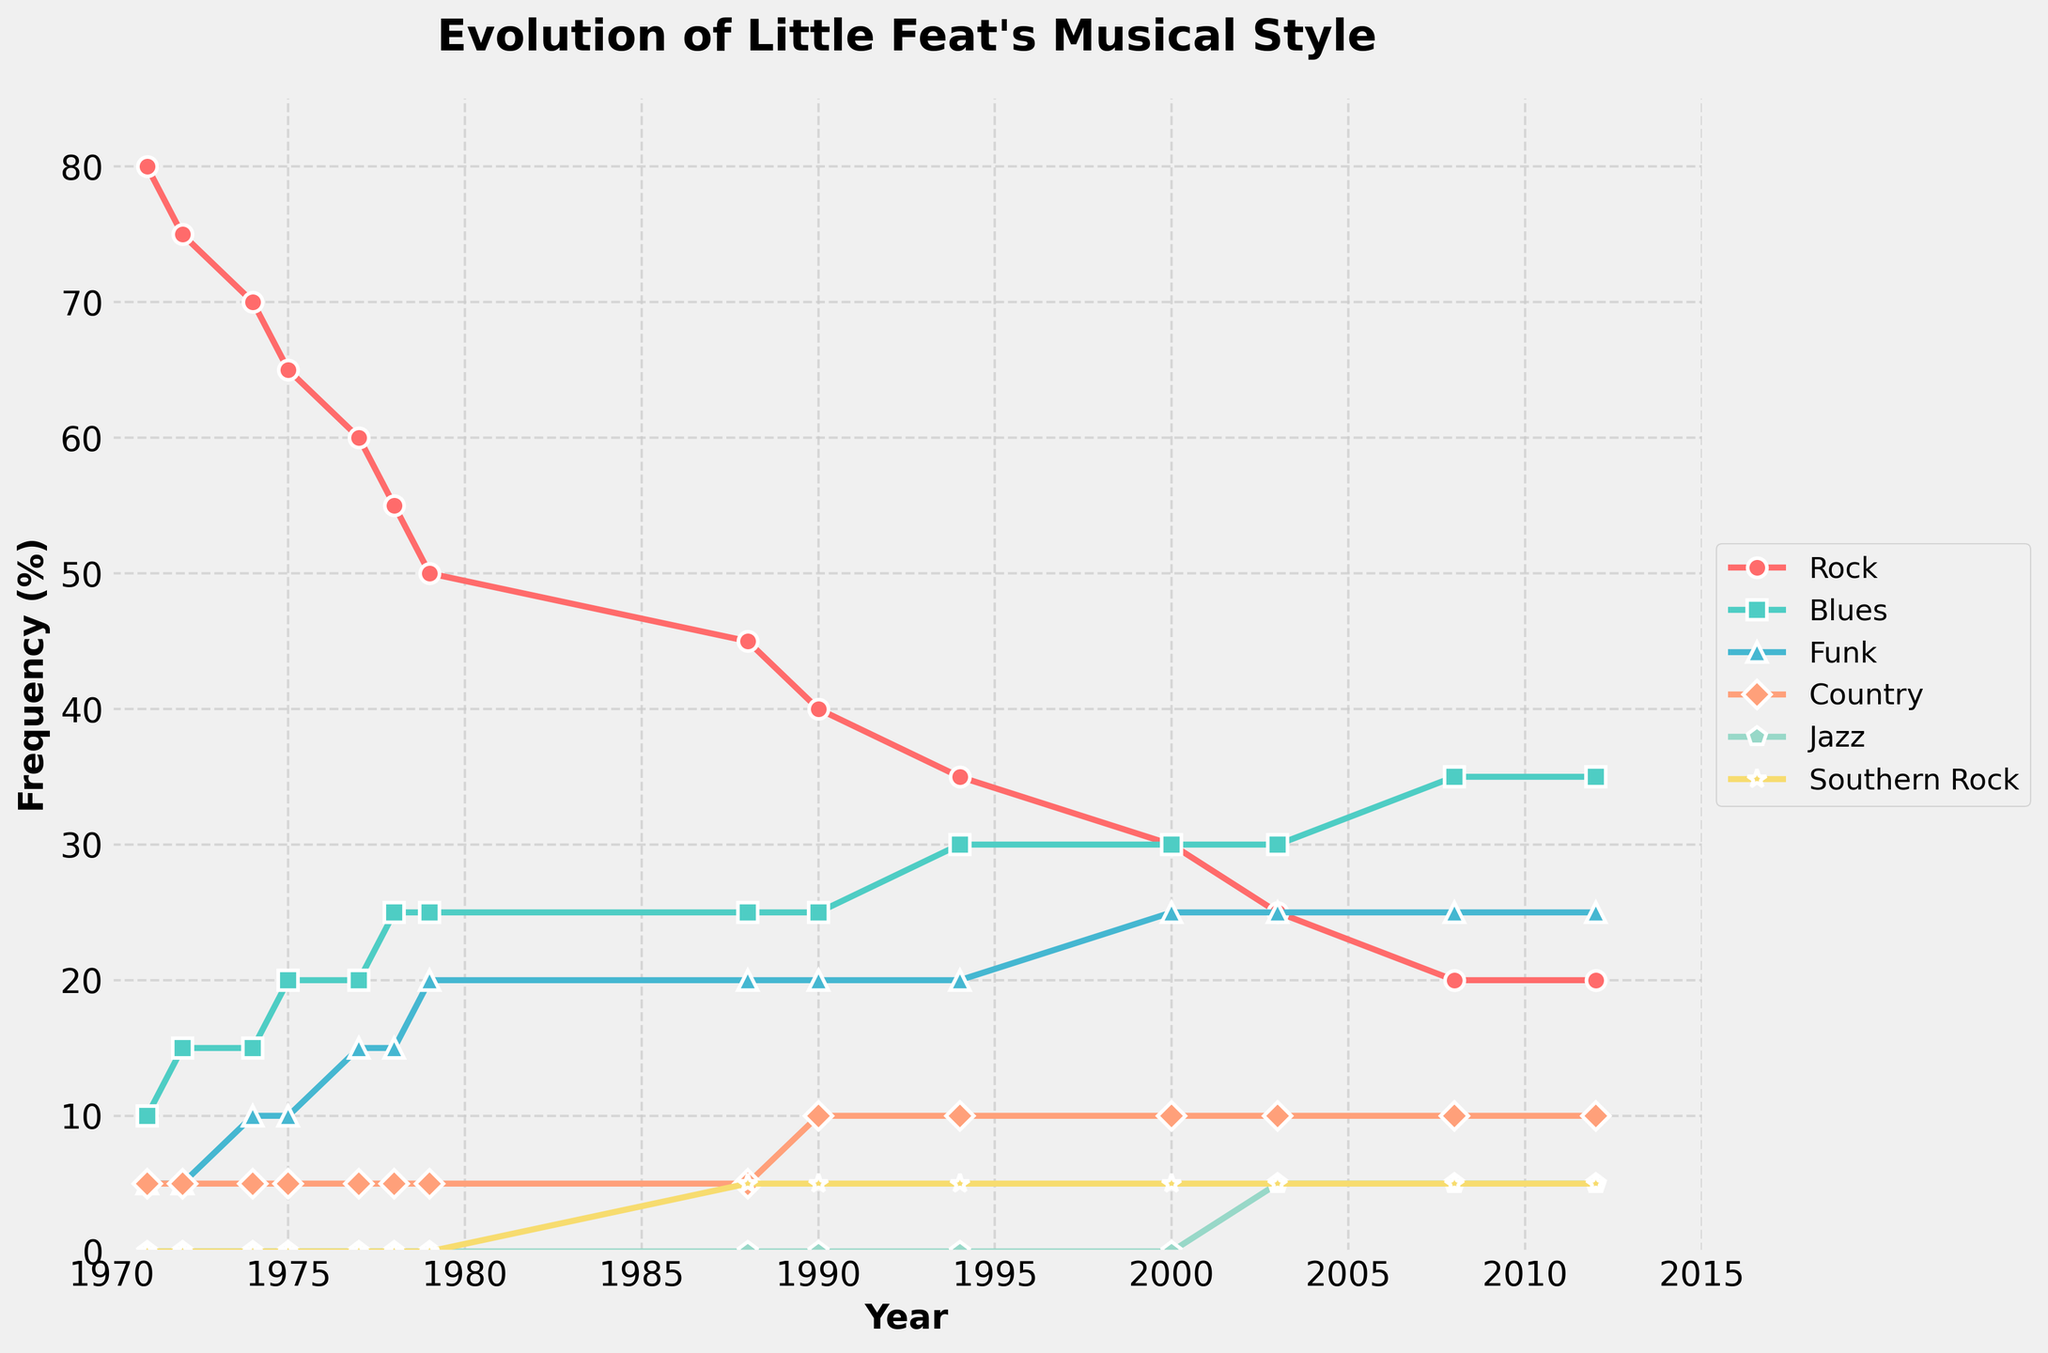What genre saw the largest increase in frequency from 1971 to 2012? To find the largest increase, calculate the frequency difference for each genre between 1971 and 2012. Rock: 80 - 20 = 60; Blues: 35 - 10 = 25; Funk: 25 - 5 = 20; Country: 10 - 5 = 5; Jazz: 5 - 0 = 5; Southern Rock: 5 - 0 = 5. Rock had the largest decrease, so interpret as least increase.
Answer: Blues and Funk Which genre had the highest frequency in 1975 and how did it change by 2012? In 1975, Rock had the highest frequency at 65%. By 2012, Rock decreased to 20%.
Answer: Rock, decreased to 20% Did the frequency of Jazz ever exceed that of Country? Visually compare the lines representing Jazz and Country. Jazz first appears in 2003 at 5%, the same frequency as Country in that year. Jazz never surpasses Country.
Answer: No Between which years did Funk see the most significant rise in frequency? Look for the steepest incline in the Funk line. The most noticeable rise is between 1974 (10%) and 1979 (20%).
Answer: 1974-1979 How does the frequency of Southern Rock in 1990 compare to that of Blues in 2008? In 1990, Southern Rock is at 5%. In 2008, Blues is at 35%. Compare 5% vs 35%.
Answer: Blues is higher in 2008 (5% vs 35%) Which period saw a continuous decline in Rock frequency? Identify periods where the Rock frequency line consistently falls. From 1971 (80%) to 2012 (20%), Rock shows a continuous decline.
Answer: 1971-2012 Compare the frequency of Funk and Blues in 2000. Which was more predominant and by what margin? In 2000, Funk is at 25% and Blues at 30%. The difference is 30% - 25% = 5%.
Answer: Blues by 5% What was the overall trend of Country music in Little Feat’s discography from 1971 to 2012? Examine the Country line from start to end. It remains relatively constant at 5%.
Answer: Relatively constant In what year did all six genres appear in Little Feat's discography for the first time? Identify the year when each genre first has a non-zero frequency. All genres first appear together in 2003.
Answer: 2003 Calculate the average frequency of Rock music between 1971 and 2012. Add the Rock frequencies from 1971 to 2012 and divide by the number of data points: (80 + 75 + 70 + 65 + 60 + 55 + 50 + 45 + 40 + 35 + 30 + 25 + 20 + 20)/14 = 44.64.
Answer: 44.64 